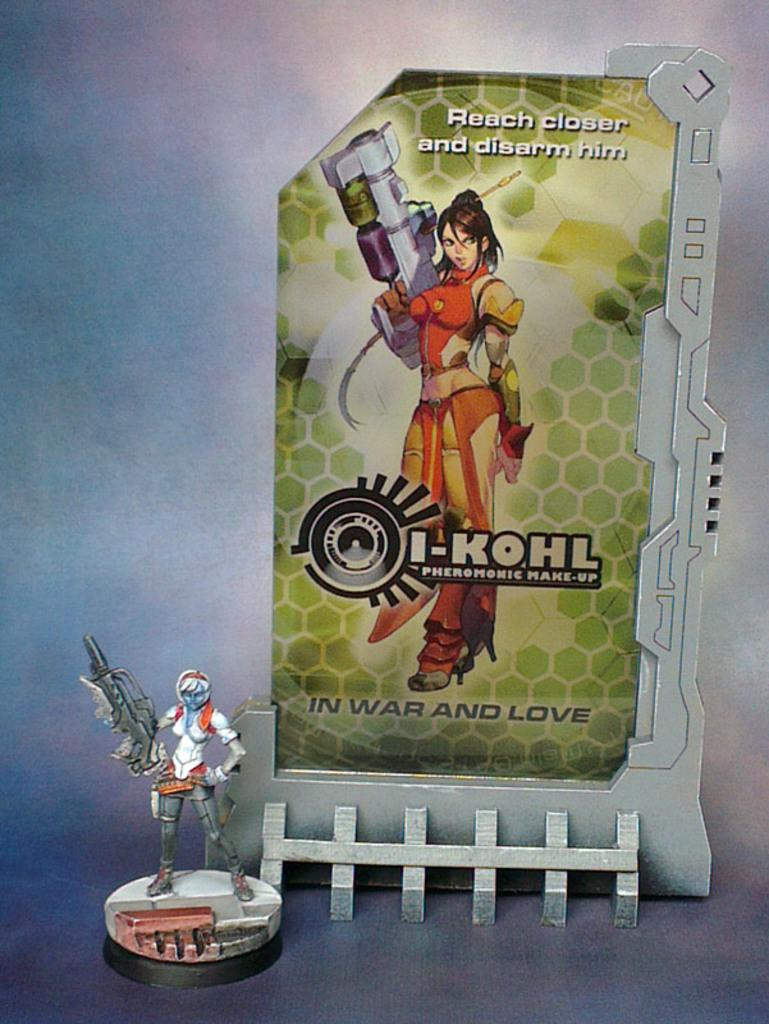<image>
Present a compact description of the photo's key features. an ad for i-kohl makeup with a figure in front of it 